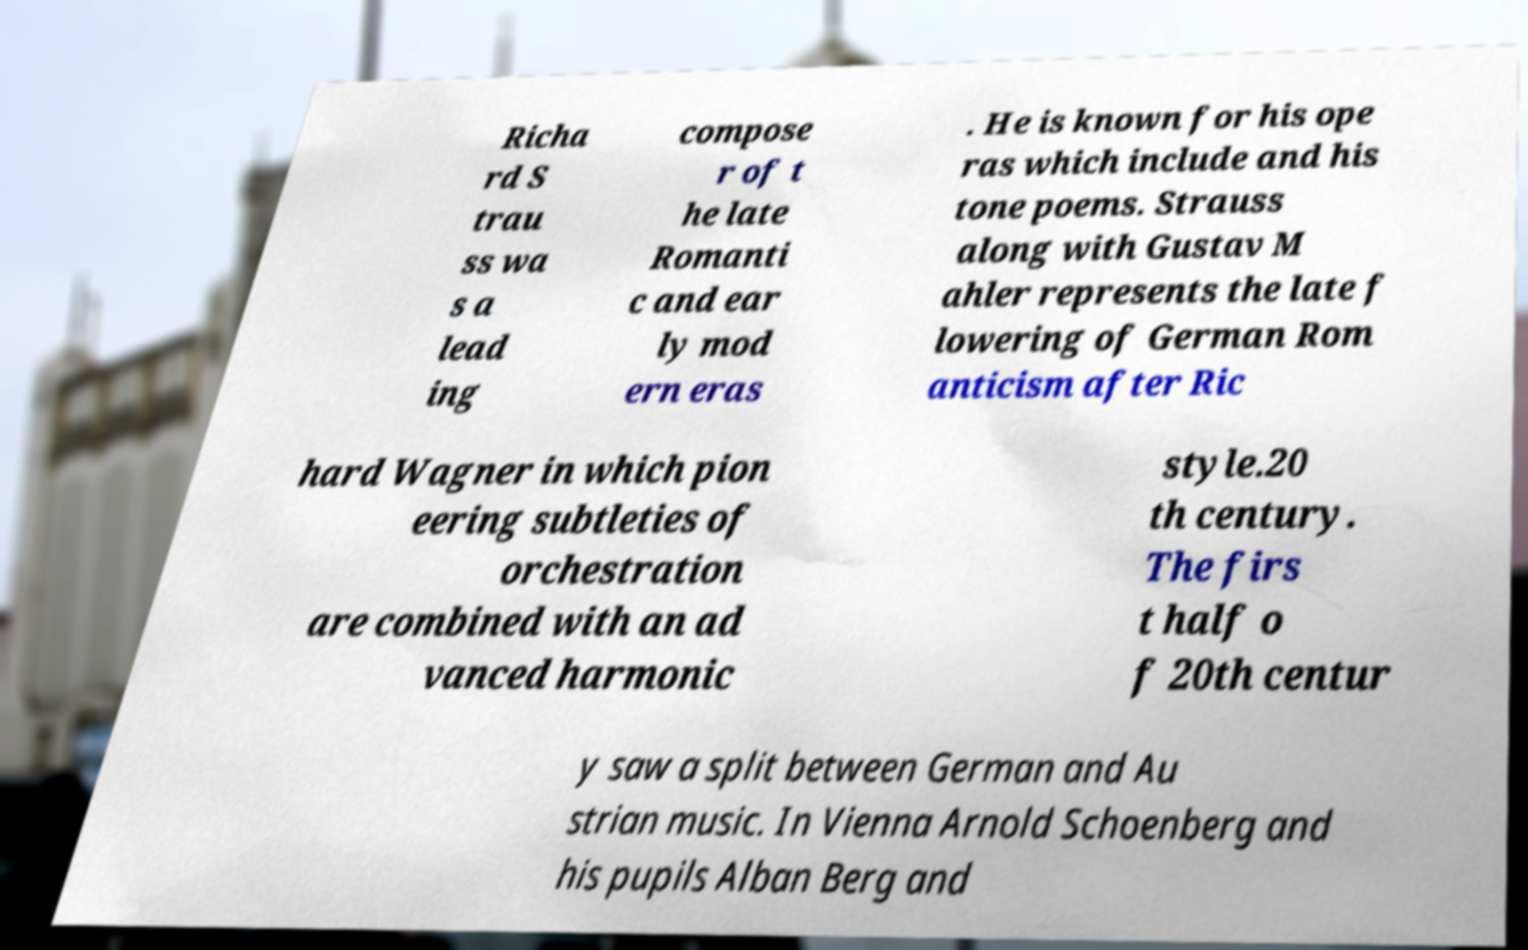Could you assist in decoding the text presented in this image and type it out clearly? Richa rd S trau ss wa s a lead ing compose r of t he late Romanti c and ear ly mod ern eras . He is known for his ope ras which include and his tone poems. Strauss along with Gustav M ahler represents the late f lowering of German Rom anticism after Ric hard Wagner in which pion eering subtleties of orchestration are combined with an ad vanced harmonic style.20 th century. The firs t half o f 20th centur y saw a split between German and Au strian music. In Vienna Arnold Schoenberg and his pupils Alban Berg and 